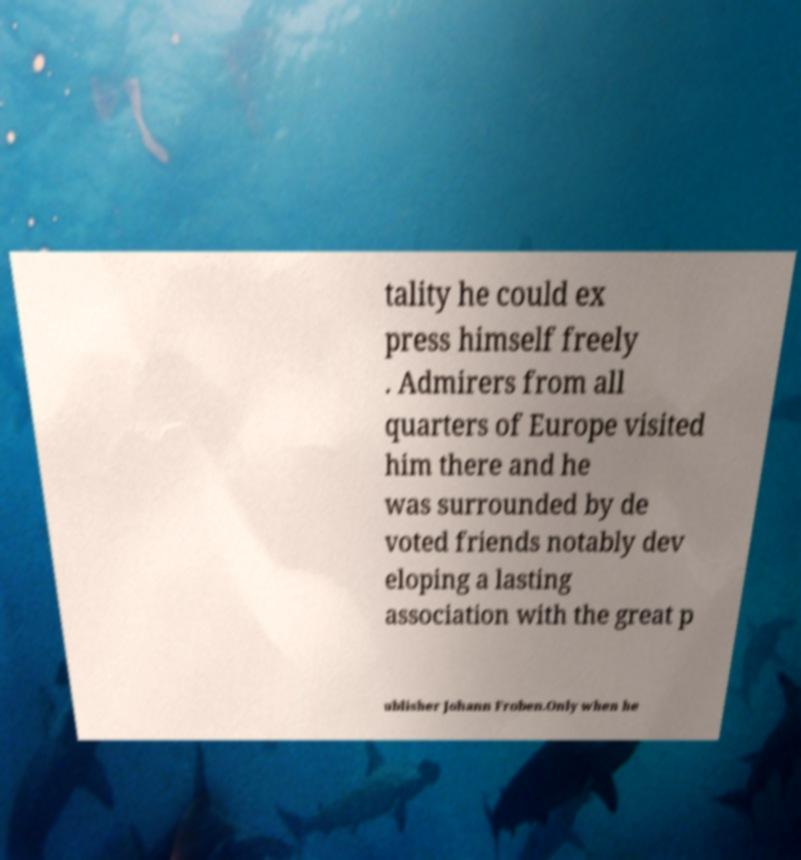I need the written content from this picture converted into text. Can you do that? tality he could ex press himself freely . Admirers from all quarters of Europe visited him there and he was surrounded by de voted friends notably dev eloping a lasting association with the great p ublisher Johann Froben.Only when he 